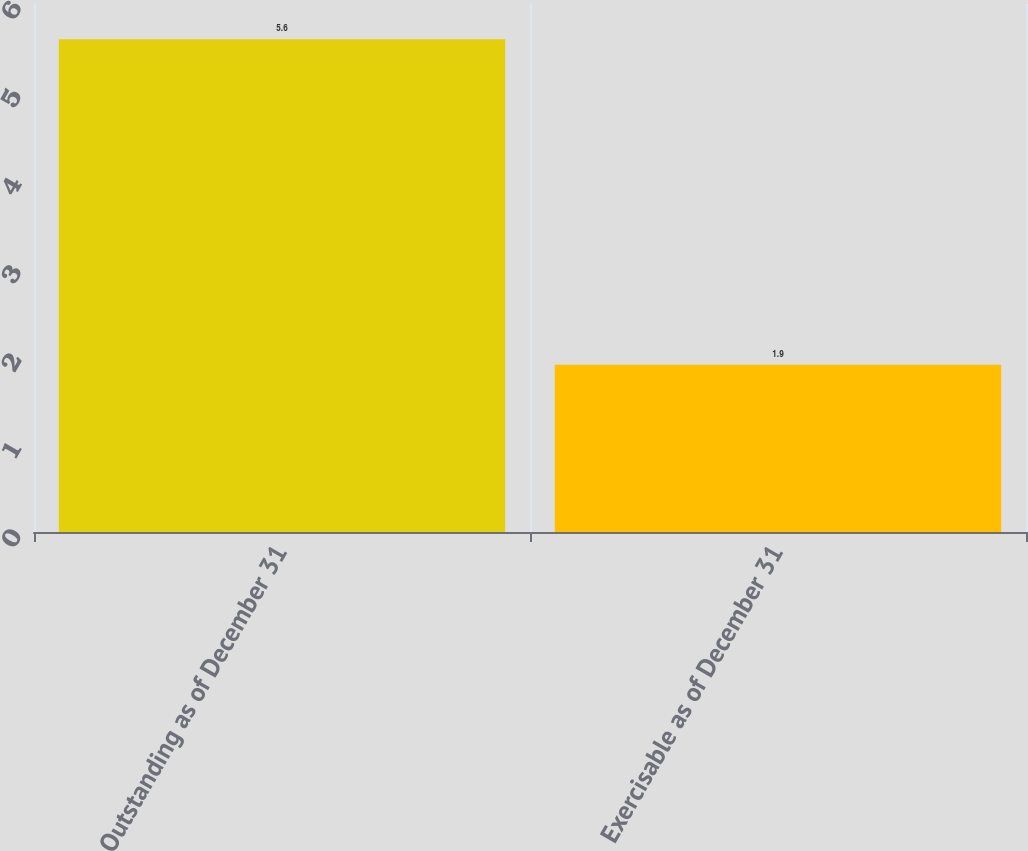<chart> <loc_0><loc_0><loc_500><loc_500><bar_chart><fcel>Outstanding as of December 31<fcel>Exercisable as of December 31<nl><fcel>5.6<fcel>1.9<nl></chart> 